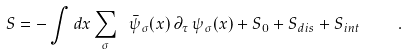<formula> <loc_0><loc_0><loc_500><loc_500>S = - \int d x \sum _ { \sigma } \ \bar { \psi } _ { \sigma } ( x ) \, \partial _ { \tau } \, \psi _ { \sigma } ( x ) + S _ { 0 } + S _ { d i s } + S _ { i n t } \quad .</formula> 